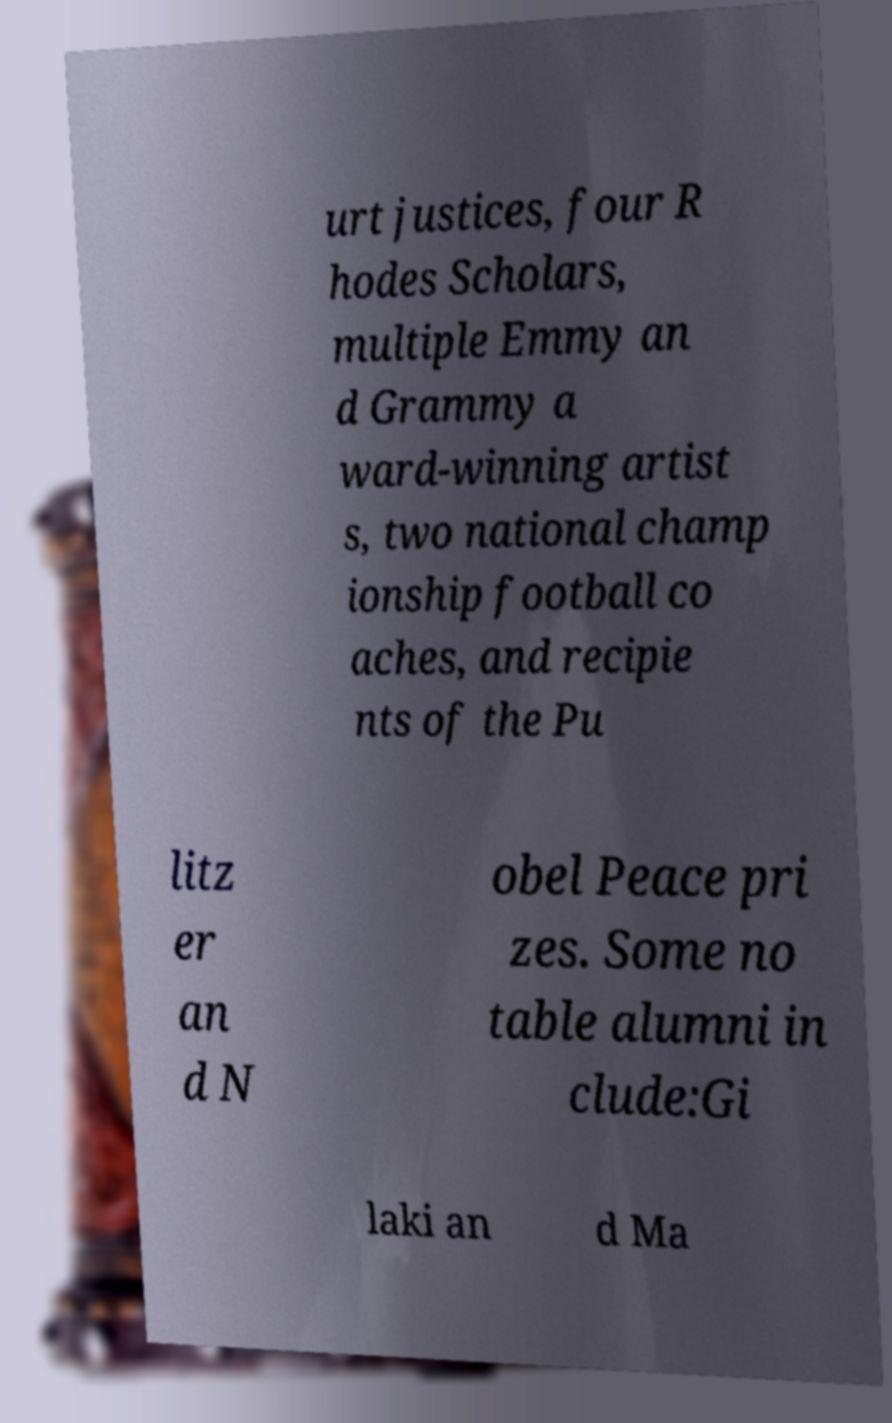What messages or text are displayed in this image? I need them in a readable, typed format. urt justices, four R hodes Scholars, multiple Emmy an d Grammy a ward-winning artist s, two national champ ionship football co aches, and recipie nts of the Pu litz er an d N obel Peace pri zes. Some no table alumni in clude:Gi laki an d Ma 